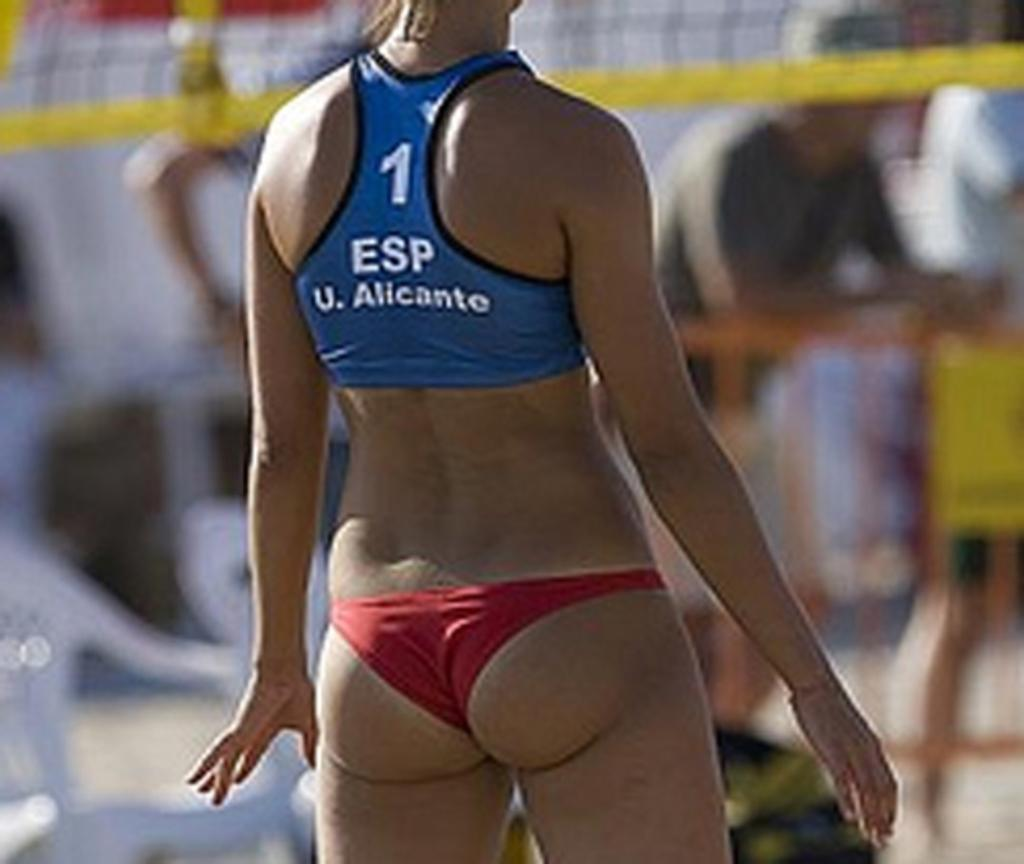<image>
Relay a brief, clear account of the picture shown. A female volleyball player wearing a top that reads 1 esp u. alicanto 